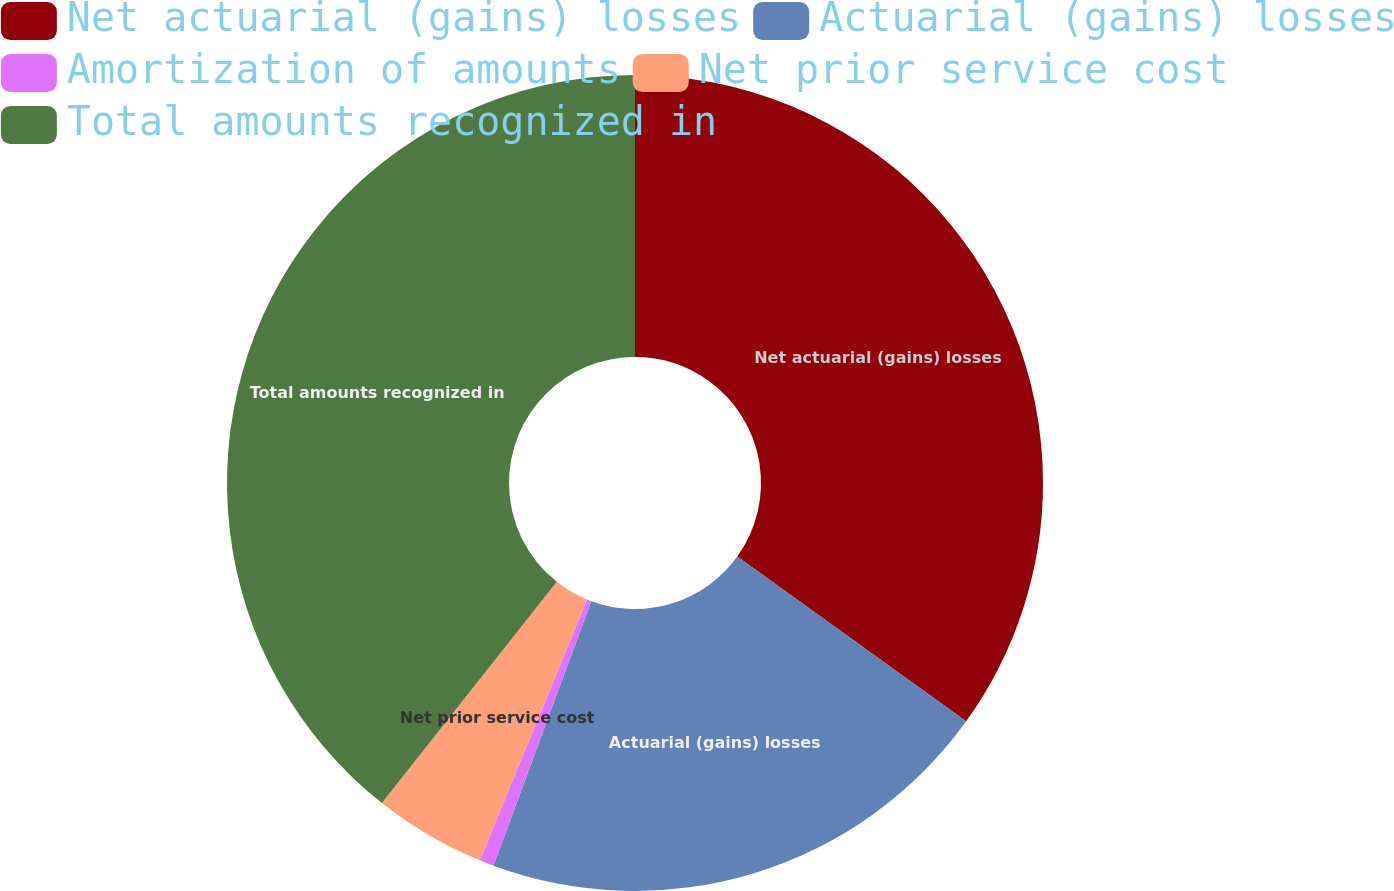<chart> <loc_0><loc_0><loc_500><loc_500><pie_chart><fcel>Net actuarial (gains) losses<fcel>Actuarial (gains) losses<fcel>Amortization of amounts<fcel>Net prior service cost<fcel>Total amounts recognized in<nl><fcel>34.93%<fcel>20.71%<fcel>0.57%<fcel>4.44%<fcel>39.35%<nl></chart> 